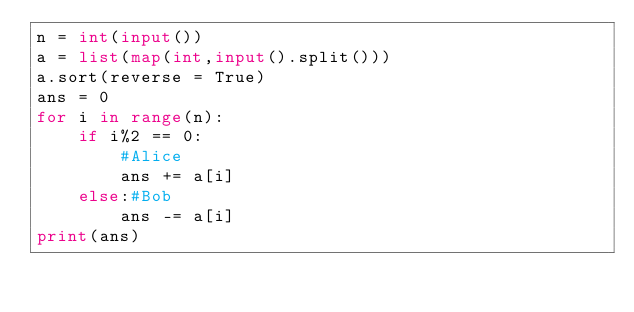<code> <loc_0><loc_0><loc_500><loc_500><_Python_>n = int(input())
a = list(map(int,input().split()))
a.sort(reverse = True)
ans = 0
for i in range(n):
    if i%2 == 0:
        #Alice
        ans += a[i]
    else:#Bob
        ans -= a[i]
print(ans)</code> 